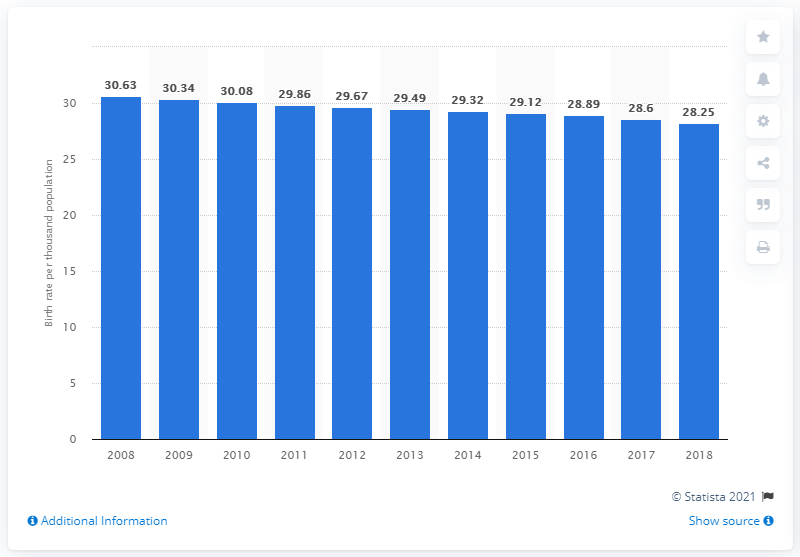Indicate a few pertinent items in this graphic. The crude birth rate in Pakistan in 2018 was 28.25. 